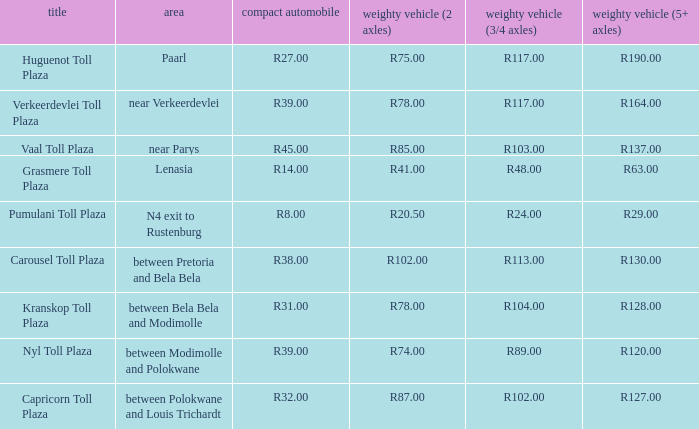What is the location of the Carousel toll plaza? Between pretoria and bela bela. 